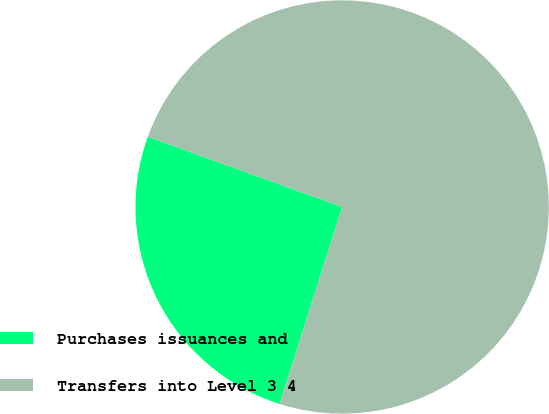Convert chart. <chart><loc_0><loc_0><loc_500><loc_500><pie_chart><fcel>Purchases issuances and<fcel>Transfers into Level 3 4<nl><fcel>25.63%<fcel>74.37%<nl></chart> 